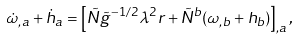<formula> <loc_0><loc_0><loc_500><loc_500>\dot { \omega } _ { , a } + \dot { h } _ { a } = \left [ \tilde { N } \tilde { g } ^ { - 1 / 2 } \lambda ^ { 2 } r + \tilde { N } ^ { b } ( \omega _ { , b } + h _ { b } ) \right ] _ { , a } ,</formula> 